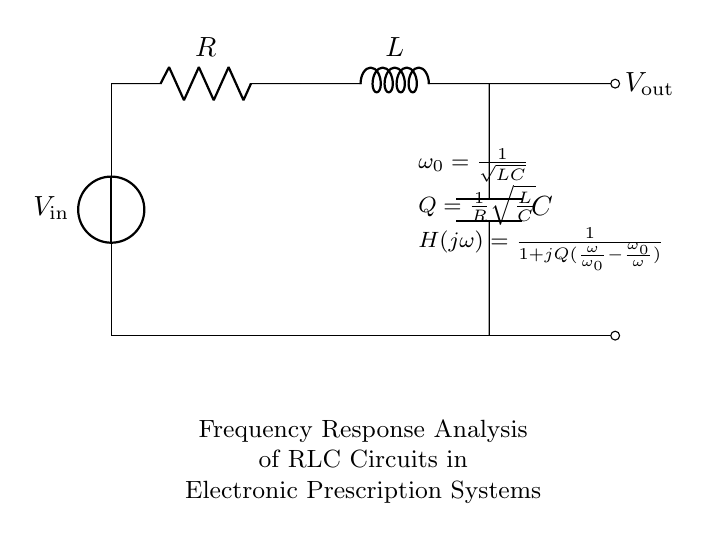What are the components in the circuit? The components in the circuit include a voltage source, a resistor, an inductor, and a capacitor. These are clearly labeled in the circuit diagram.
Answer: voltage source, resistor, inductor, capacitor What is the role of the resistor in the RLC circuit? The resistor in the RLC circuit provides damping, which helps control the bandwidth and stability of the response to varying frequencies. It impacts the quality factor of the circuit.
Answer: Damping What is the resonant frequency formula depicted in the diagram? The formula given for resonant frequency is ω₀ = 1 / √(LC). This relates the components of the circuit to the natural frequency at which it will oscillate.
Answer: ω₀ = 1 / √(LC) How does the quality factor Q relate to R and L in the circuit? The quality factor Q is given by the formula Q = 1 / R √(L / C). This indicates that higher resistance leads to a lower quality factor, affecting the peak response of the circuit.
Answer: Q = 1 / R √(L / C) What is H(jω) in the context of this circuit? H(jω) is the transfer function of the RLC circuit and is given by H(jω) = 1 / [1 + jQ(ω / ω₀ - ω₀ / ω)]. This describes how the amplitude and phase of the output voltage relate to the input voltage across different frequencies.
Answer: H(jω) = 1 / [1 + jQ(ω / ω₀ - ω₀ / ω)] At what frequency does the circuit resonate based on the components? The circuit resonates at the frequency determined by the values of L and C, which can be calculated using the resonant frequency formula ω₀ = 1 / √(LC). Specific values will yield a numerical answer.
Answer: ω₀ = 1 / √(LC) 